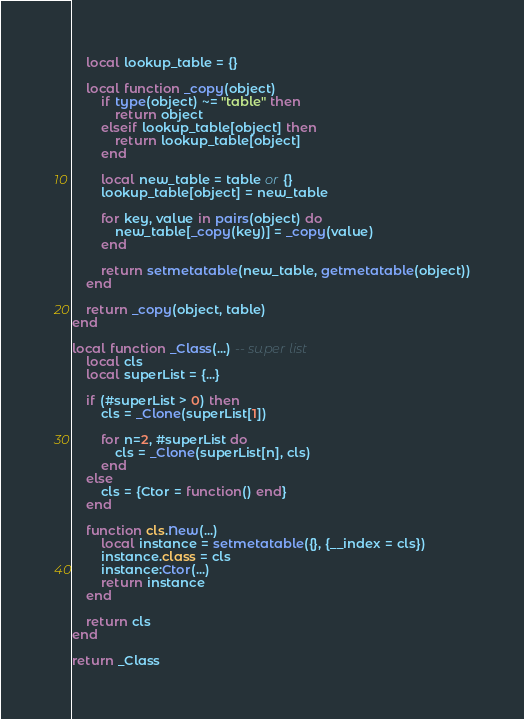Convert code to text. <code><loc_0><loc_0><loc_500><loc_500><_Lua_>    local lookup_table = {}

    local function _copy(object)
        if type(object) ~= "table" then
            return object
        elseif lookup_table[object] then
            return lookup_table[object]
        end

        local new_table = table or {}
        lookup_table[object] = new_table

        for key, value in pairs(object) do
            new_table[_copy(key)] = _copy(value)
        end

        return setmetatable(new_table, getmetatable(object))
    end

    return _copy(object, table)
end

local function _Class(...) -- super list
    local cls
	local superList = {...}

    if (#superList > 0) then
		cls = _Clone(superList[1])
		
        for n=2, #superList do
			cls = _Clone(superList[n], cls)
		end
    else
        cls = {Ctor = function() end}
    end

    function cls.New(...)
        local instance = setmetatable({}, {__index = cls})
        instance.class = cls
        instance:Ctor(...)
        return instance
    end    

    return cls
end

return _Class</code> 